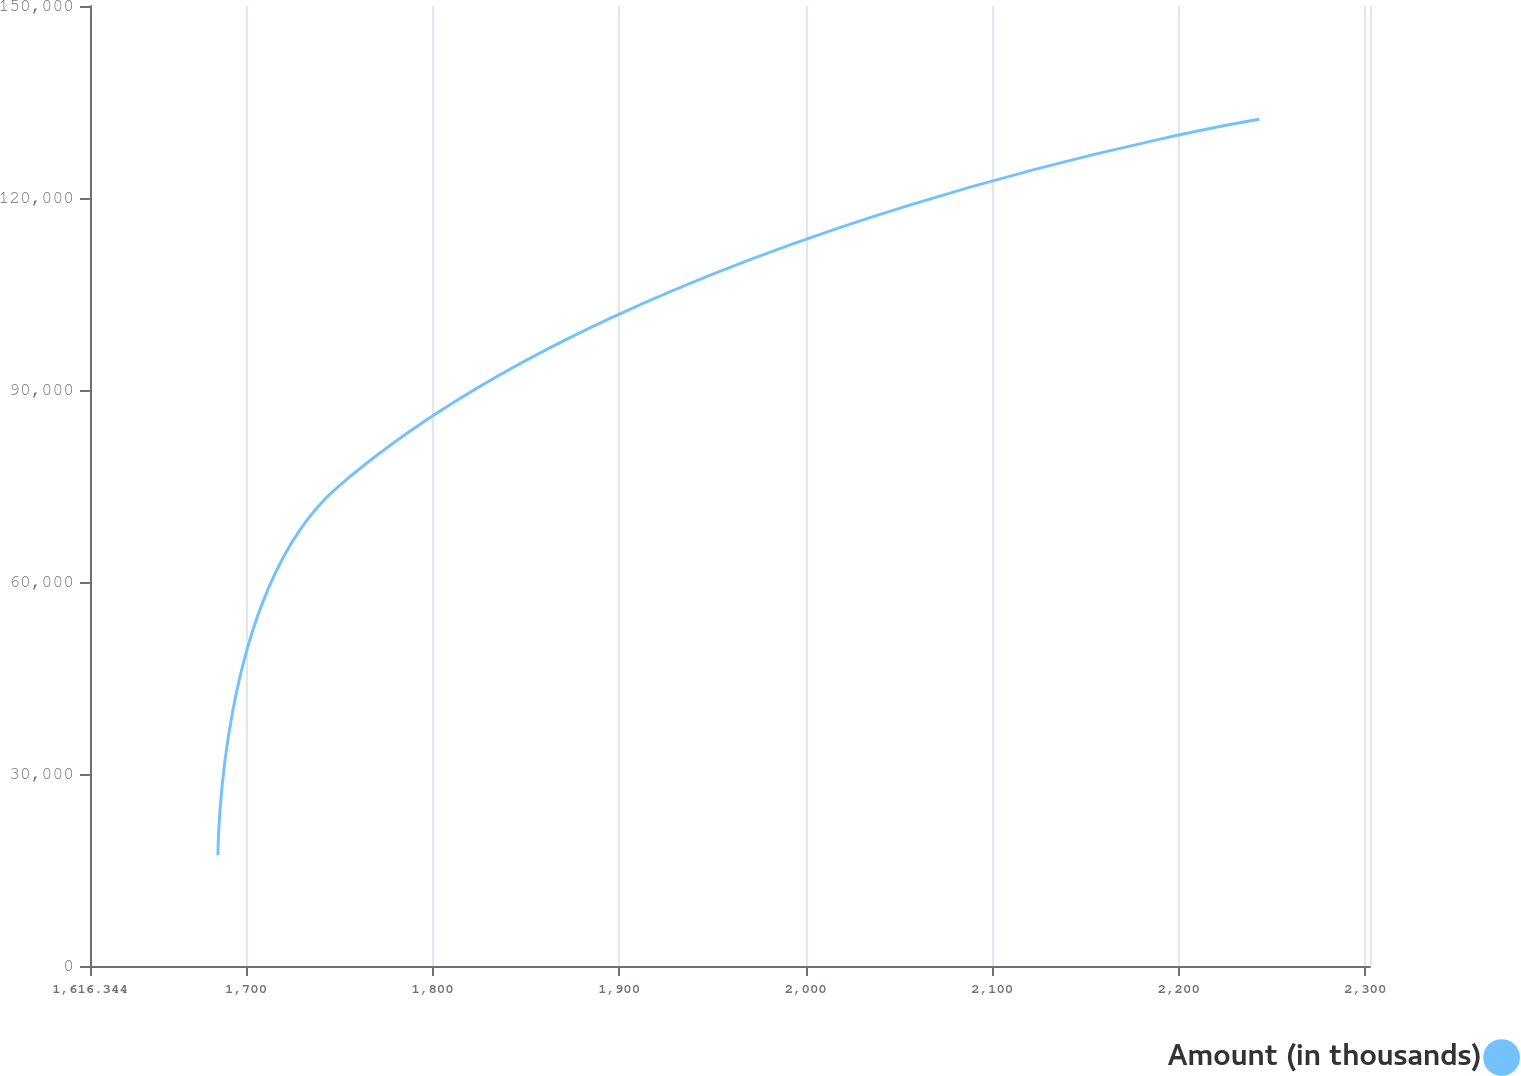Convert chart to OTSL. <chart><loc_0><loc_0><loc_500><loc_500><line_chart><ecel><fcel>Amount (in thousands)<nl><fcel>1684.96<fcel>17302.5<nl><fcel>1748.97<fcel>74799.8<nl><fcel>2243.1<fcel>132297<nl><fcel>2307.11<fcel>189794<nl><fcel>2371.12<fcel>592276<nl></chart> 